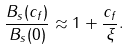Convert formula to latex. <formula><loc_0><loc_0><loc_500><loc_500>\frac { B _ { s } ( c _ { f } ) } { B _ { s } ( 0 ) } \approx 1 + \frac { c _ { f } } { \xi } .</formula> 